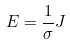Convert formula to latex. <formula><loc_0><loc_0><loc_500><loc_500>E = \frac { 1 } { \sigma } J</formula> 